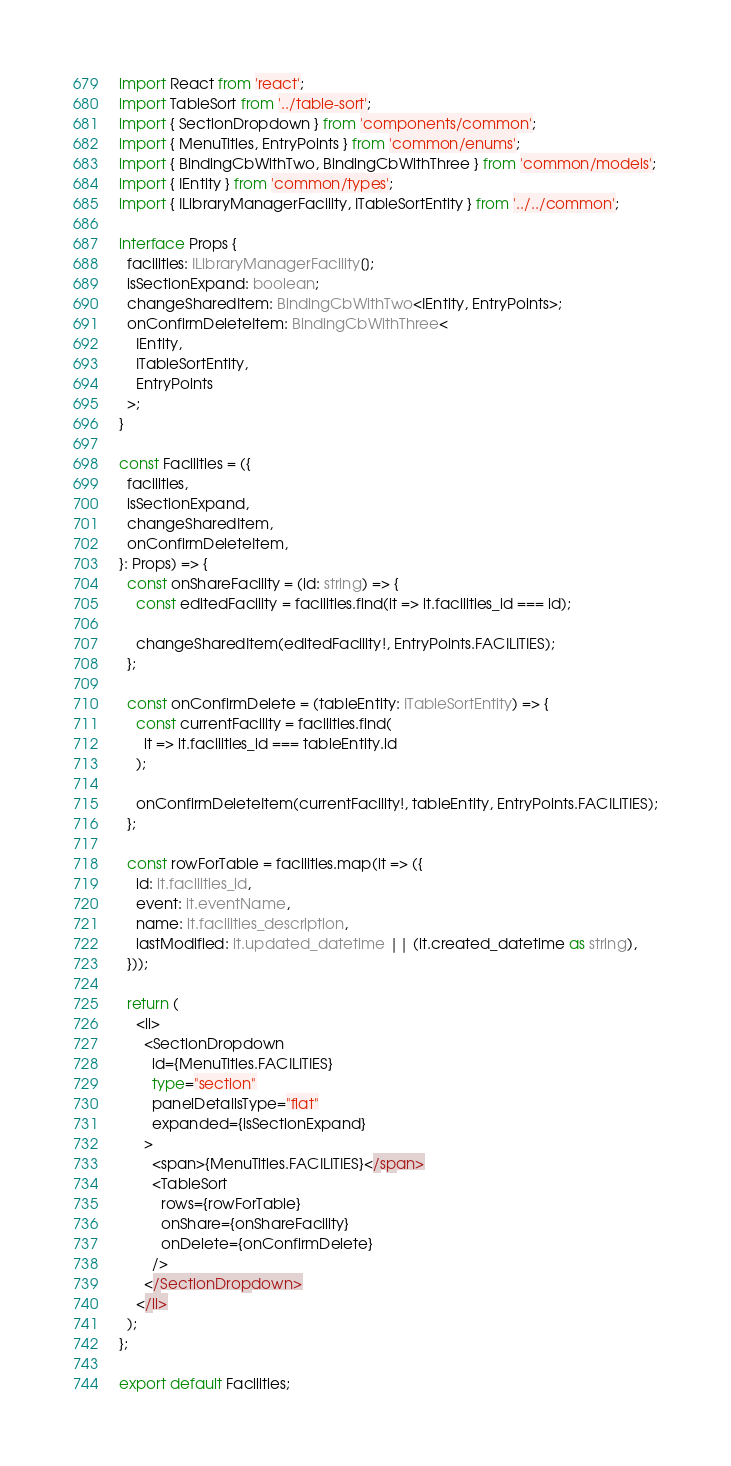Convert code to text. <code><loc_0><loc_0><loc_500><loc_500><_TypeScript_>import React from 'react';
import TableSort from '../table-sort';
import { SectionDropdown } from 'components/common';
import { MenuTitles, EntryPoints } from 'common/enums';
import { BindingCbWithTwo, BindingCbWithThree } from 'common/models';
import { IEntity } from 'common/types';
import { ILibraryManagerFacility, ITableSortEntity } from '../../common';

interface Props {
  facilities: ILibraryManagerFacility[];
  isSectionExpand: boolean;
  changeSharedItem: BindingCbWithTwo<IEntity, EntryPoints>;
  onConfirmDeleteItem: BindingCbWithThree<
    IEntity,
    ITableSortEntity,
    EntryPoints
  >;
}

const Facilities = ({
  facilities,
  isSectionExpand,
  changeSharedItem,
  onConfirmDeleteItem,
}: Props) => {
  const onShareFacility = (id: string) => {
    const editedFacility = facilities.find(it => it.facilities_id === id);

    changeSharedItem(editedFacility!, EntryPoints.FACILITIES);
  };

  const onConfirmDelete = (tableEntity: ITableSortEntity) => {
    const currentFacility = facilities.find(
      it => it.facilities_id === tableEntity.id
    );

    onConfirmDeleteItem(currentFacility!, tableEntity, EntryPoints.FACILITIES);
  };

  const rowForTable = facilities.map(it => ({
    id: it.facilities_id,
    event: it.eventName,
    name: it.facilities_description,
    lastModified: it.updated_datetime || (it.created_datetime as string),
  }));

  return (
    <li>
      <SectionDropdown
        id={MenuTitles.FACILITIES}
        type="section"
        panelDetailsType="flat"
        expanded={isSectionExpand}
      >
        <span>{MenuTitles.FACILITIES}</span>
        <TableSort
          rows={rowForTable}
          onShare={onShareFacility}
          onDelete={onConfirmDelete}
        />
      </SectionDropdown>
    </li>
  );
};

export default Facilities;
</code> 